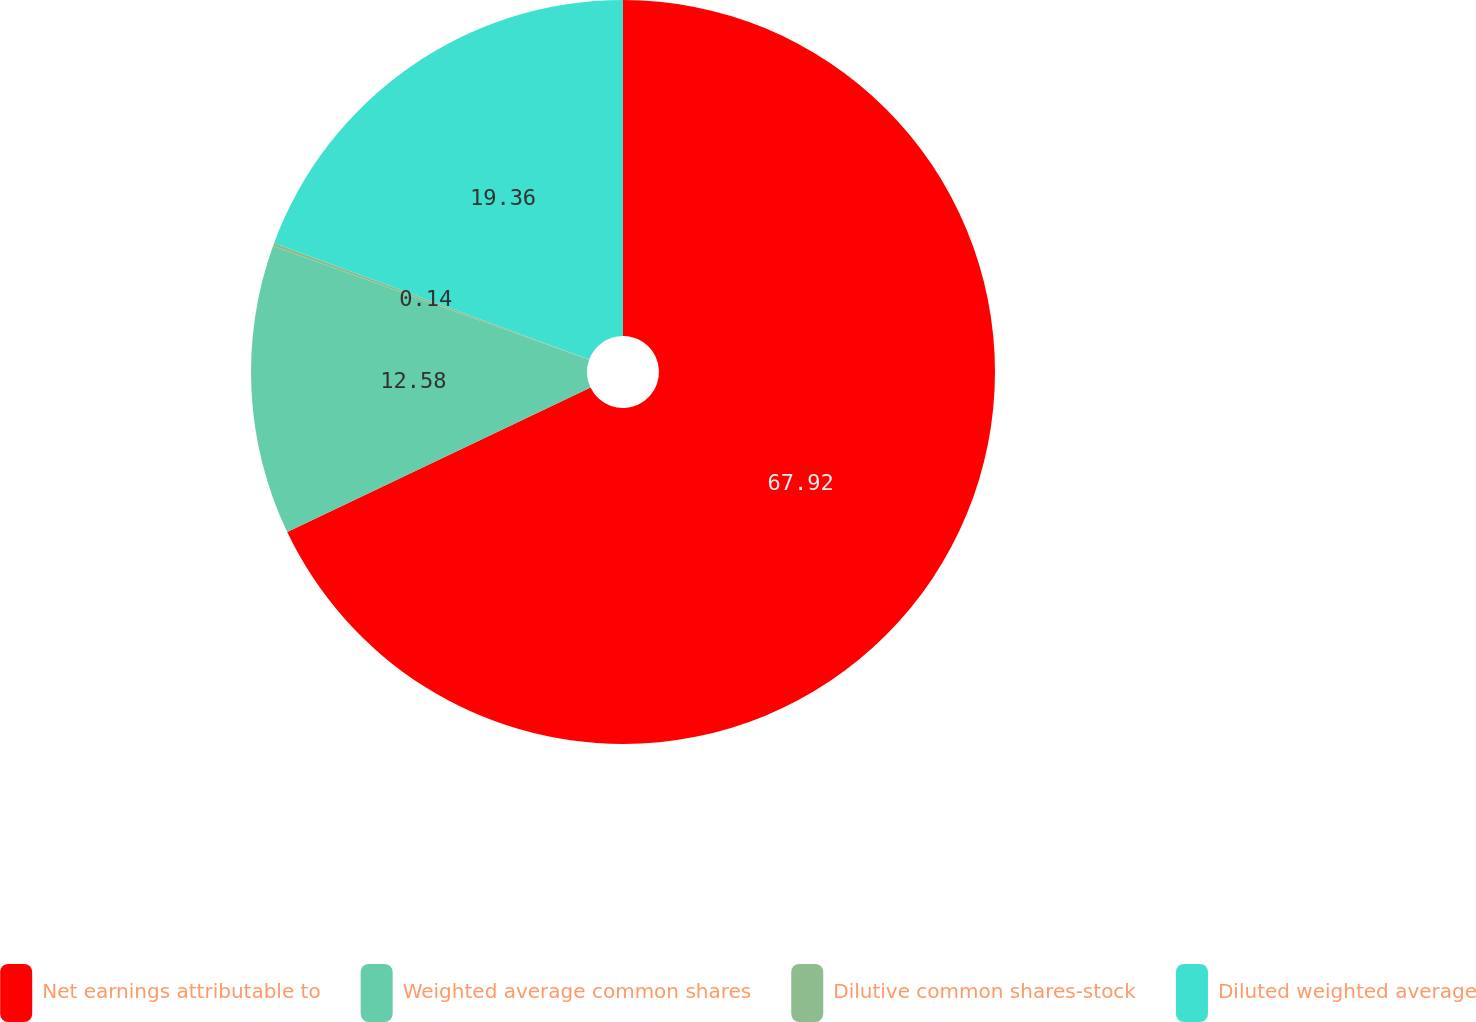Convert chart to OTSL. <chart><loc_0><loc_0><loc_500><loc_500><pie_chart><fcel>Net earnings attributable to<fcel>Weighted average common shares<fcel>Dilutive common shares-stock<fcel>Diluted weighted average<nl><fcel>67.92%<fcel>12.58%<fcel>0.14%<fcel>19.36%<nl></chart> 